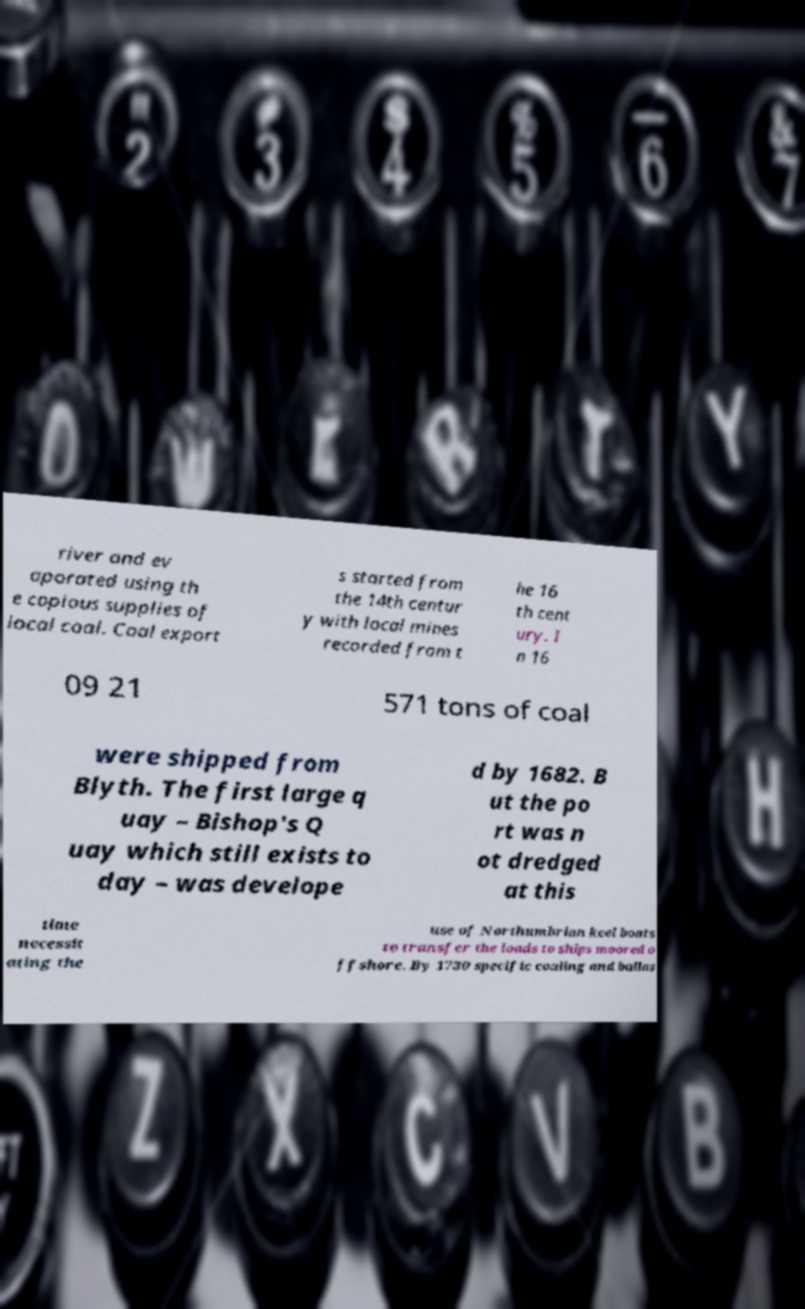Can you read and provide the text displayed in the image?This photo seems to have some interesting text. Can you extract and type it out for me? river and ev aporated using th e copious supplies of local coal. Coal export s started from the 14th centur y with local mines recorded from t he 16 th cent ury. I n 16 09 21 571 tons of coal were shipped from Blyth. The first large q uay – Bishop's Q uay which still exists to day – was develope d by 1682. B ut the po rt was n ot dredged at this time necessit ating the use of Northumbrian keel boats to transfer the loads to ships moored o ffshore. By 1730 specific coaling and ballas 